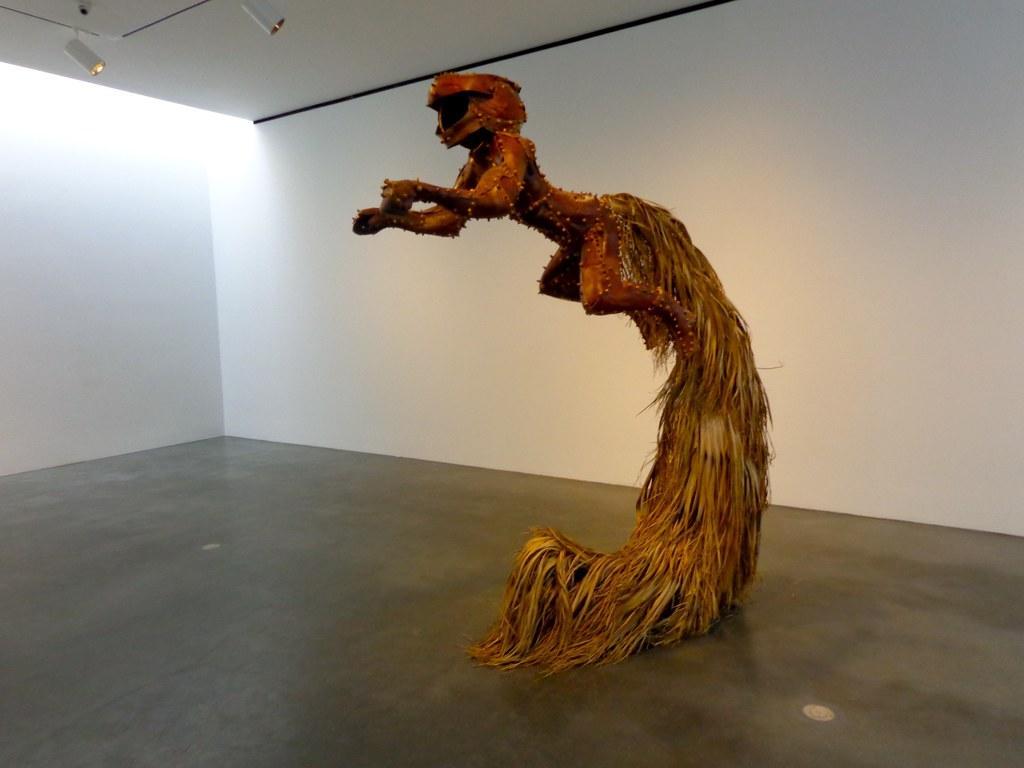Could you give a brief overview of what you see in this image? This image is taken indoors. In the background there is a wall. At the bottom of the image there is a floor. At the top of the image there is a ceiling and there is a CC camera. In the middle of the image there is an artwork with metal and feathers. 